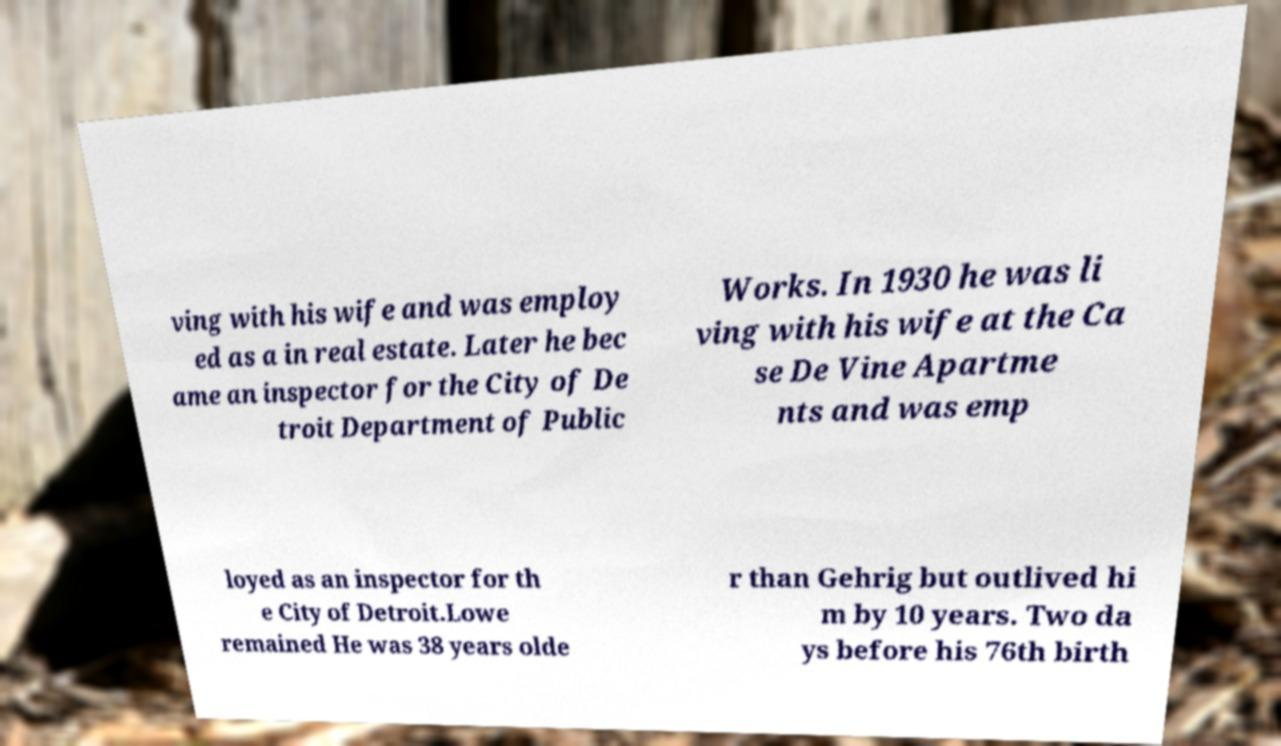There's text embedded in this image that I need extracted. Can you transcribe it verbatim? ving with his wife and was employ ed as a in real estate. Later he bec ame an inspector for the City of De troit Department of Public Works. In 1930 he was li ving with his wife at the Ca se De Vine Apartme nts and was emp loyed as an inspector for th e City of Detroit.Lowe remained He was 38 years olde r than Gehrig but outlived hi m by 10 years. Two da ys before his 76th birth 